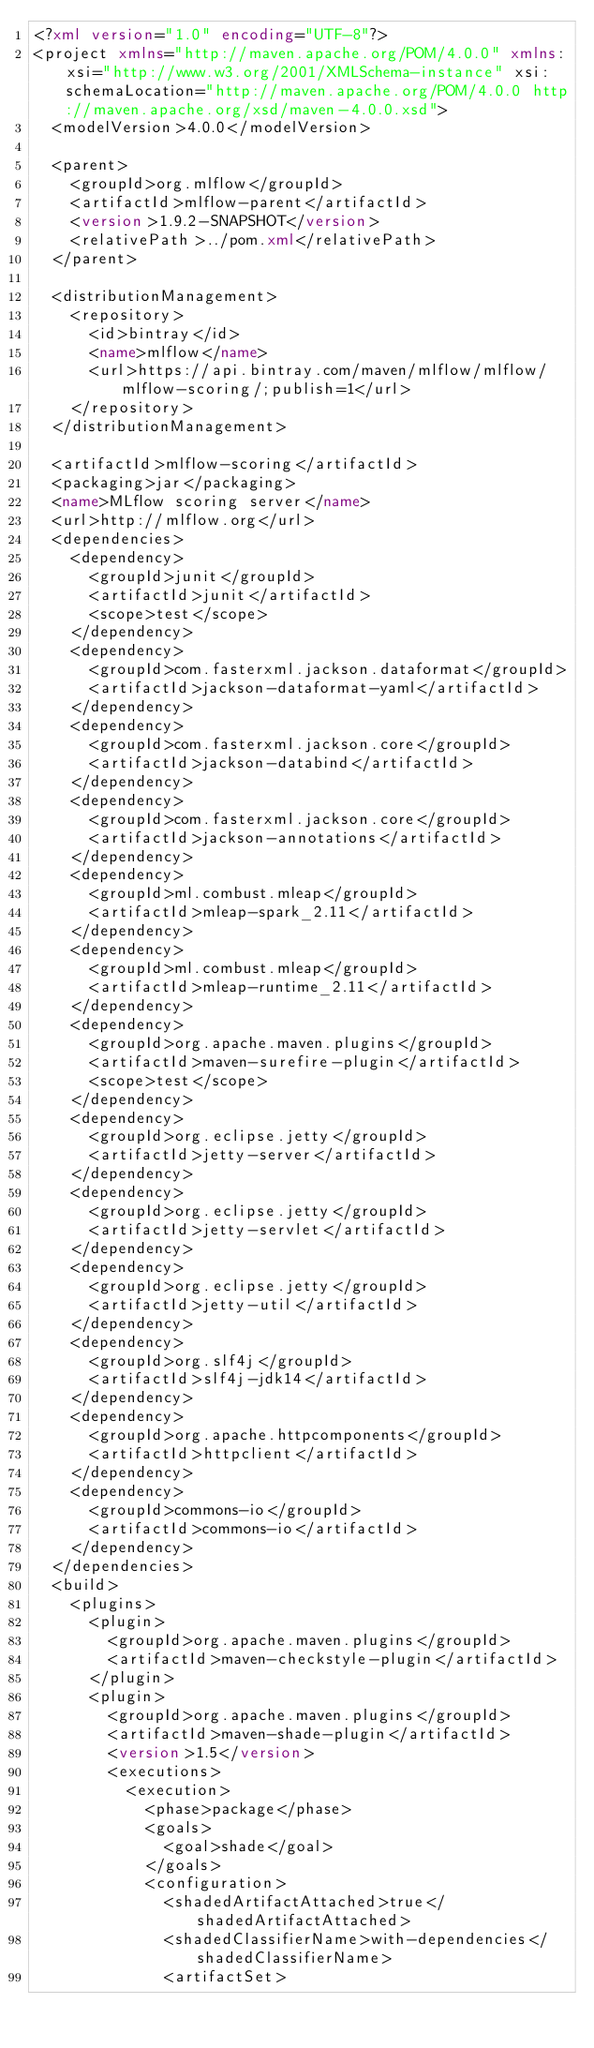Convert code to text. <code><loc_0><loc_0><loc_500><loc_500><_XML_><?xml version="1.0" encoding="UTF-8"?>
<project xmlns="http://maven.apache.org/POM/4.0.0" xmlns:xsi="http://www.w3.org/2001/XMLSchema-instance" xsi:schemaLocation="http://maven.apache.org/POM/4.0.0 http://maven.apache.org/xsd/maven-4.0.0.xsd">
  <modelVersion>4.0.0</modelVersion>

  <parent>
    <groupId>org.mlflow</groupId>
    <artifactId>mlflow-parent</artifactId>
    <version>1.9.2-SNAPSHOT</version>
    <relativePath>../pom.xml</relativePath>
  </parent>

  <distributionManagement>
    <repository>
      <id>bintray</id>
      <name>mlflow</name>
      <url>https://api.bintray.com/maven/mlflow/mlflow/mlflow-scoring/;publish=1</url>
    </repository>
  </distributionManagement>

  <artifactId>mlflow-scoring</artifactId>
  <packaging>jar</packaging>
  <name>MLflow scoring server</name>
  <url>http://mlflow.org</url>
  <dependencies>
    <dependency>
      <groupId>junit</groupId>
      <artifactId>junit</artifactId>
      <scope>test</scope>
    </dependency>
    <dependency>
      <groupId>com.fasterxml.jackson.dataformat</groupId>
      <artifactId>jackson-dataformat-yaml</artifactId>
    </dependency>
    <dependency>
      <groupId>com.fasterxml.jackson.core</groupId>
      <artifactId>jackson-databind</artifactId>
    </dependency>
    <dependency>
      <groupId>com.fasterxml.jackson.core</groupId>
      <artifactId>jackson-annotations</artifactId>
    </dependency>
    <dependency>
      <groupId>ml.combust.mleap</groupId>
      <artifactId>mleap-spark_2.11</artifactId>
    </dependency>
    <dependency>
      <groupId>ml.combust.mleap</groupId>
      <artifactId>mleap-runtime_2.11</artifactId>
    </dependency>
    <dependency>
      <groupId>org.apache.maven.plugins</groupId>
      <artifactId>maven-surefire-plugin</artifactId>
      <scope>test</scope>
    </dependency>
    <dependency>
      <groupId>org.eclipse.jetty</groupId>
      <artifactId>jetty-server</artifactId>
    </dependency>
    <dependency>
      <groupId>org.eclipse.jetty</groupId>
      <artifactId>jetty-servlet</artifactId>
    </dependency>
    <dependency>
      <groupId>org.eclipse.jetty</groupId>
      <artifactId>jetty-util</artifactId>
    </dependency>
    <dependency>
      <groupId>org.slf4j</groupId>
      <artifactId>slf4j-jdk14</artifactId>
    </dependency>
    <dependency>
      <groupId>org.apache.httpcomponents</groupId>
      <artifactId>httpclient</artifactId>
    </dependency>
    <dependency>
      <groupId>commons-io</groupId>
      <artifactId>commons-io</artifactId>
    </dependency>
  </dependencies>
  <build>
    <plugins>
      <plugin>
        <groupId>org.apache.maven.plugins</groupId>
        <artifactId>maven-checkstyle-plugin</artifactId>
      </plugin>
      <plugin>
        <groupId>org.apache.maven.plugins</groupId>
        <artifactId>maven-shade-plugin</artifactId>
        <version>1.5</version>
        <executions>
          <execution>
            <phase>package</phase>
            <goals>
              <goal>shade</goal>
            </goals>
            <configuration>
              <shadedArtifactAttached>true</shadedArtifactAttached>
              <shadedClassifierName>with-dependencies</shadedClassifierName>
              <artifactSet></code> 